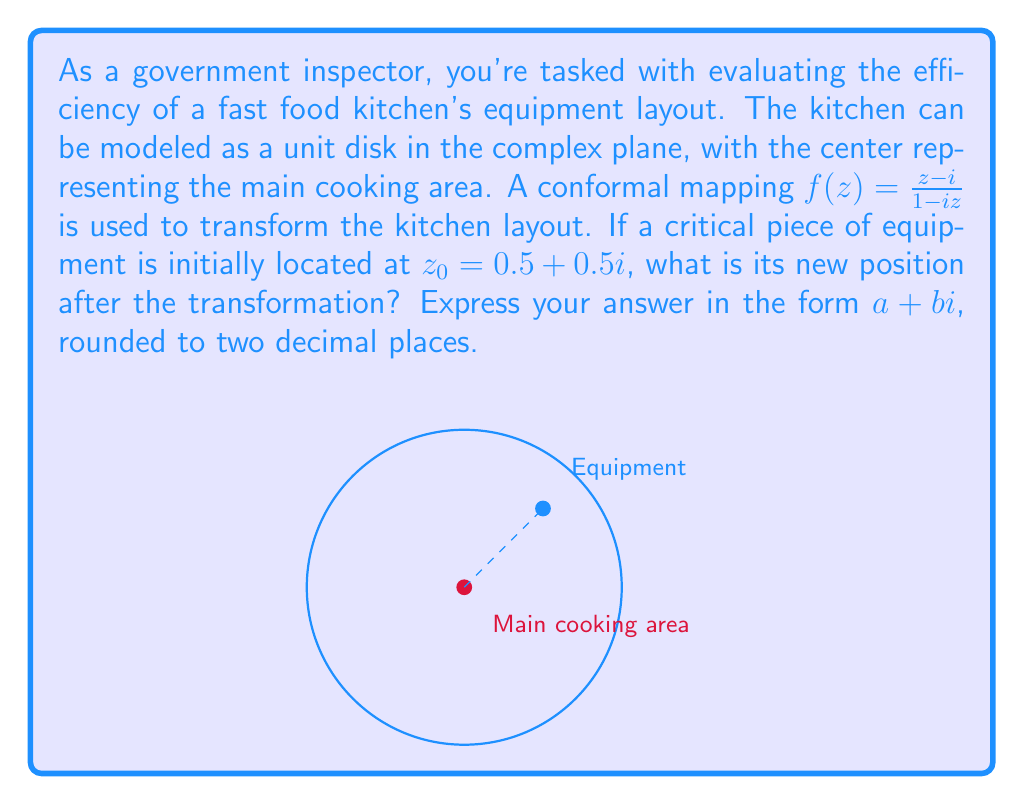Provide a solution to this math problem. Let's approach this step-by-step:

1) We are given the conformal mapping $f(z) = \frac{z-i}{1-iz}$ and the initial position $z_0 = 0.5 + 0.5i$.

2) To find the new position, we need to calculate $f(z_0)$:

   $f(z_0) = \frac{z_0-i}{1-iz_0}$

3) Let's substitute $z_0 = 0.5 + 0.5i$:

   $f(0.5 + 0.5i) = \frac{(0.5 + 0.5i)-i}{1-i(0.5 + 0.5i)}$

4) Simplify the numerator:
   
   $\frac{0.5 + 0.5i - i}{1-i(0.5 + 0.5i)} = \frac{0.5 - 0.5i}{1-i(0.5 + 0.5i)}$

5) Simplify the denominator:
   
   $\frac{0.5 - 0.5i}{1-(0.5i + 0.5i^2)} = \frac{0.5 - 0.5i}{1-0.5i + 0.5}$

6) Multiply numerator and denominator by the complex conjugate of the denominator:

   $\frac{0.5 - 0.5i}{1.5-0.5i} \cdot \frac{1.5+0.5i}{1.5+0.5i}$

7) Expand:

   $\frac{(0.5 - 0.5i)(1.5+0.5i)}{(1.5-0.5i)(1.5+0.5i)} = \frac{0.75 + 0.25i - 0.75i - 0.25i^2}{1.5^2 + 0.5^2}$

8) Simplify:

   $\frac{1 - 0.5i}{2.5} = 0.4 - 0.2i$

9) Therefore, the new position of the equipment after the transformation is $0.4 - 0.2i$.
Answer: $0.40 - 0.20i$ 